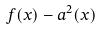Convert formula to latex. <formula><loc_0><loc_0><loc_500><loc_500>f ( x ) - a ^ { 2 } ( x )</formula> 